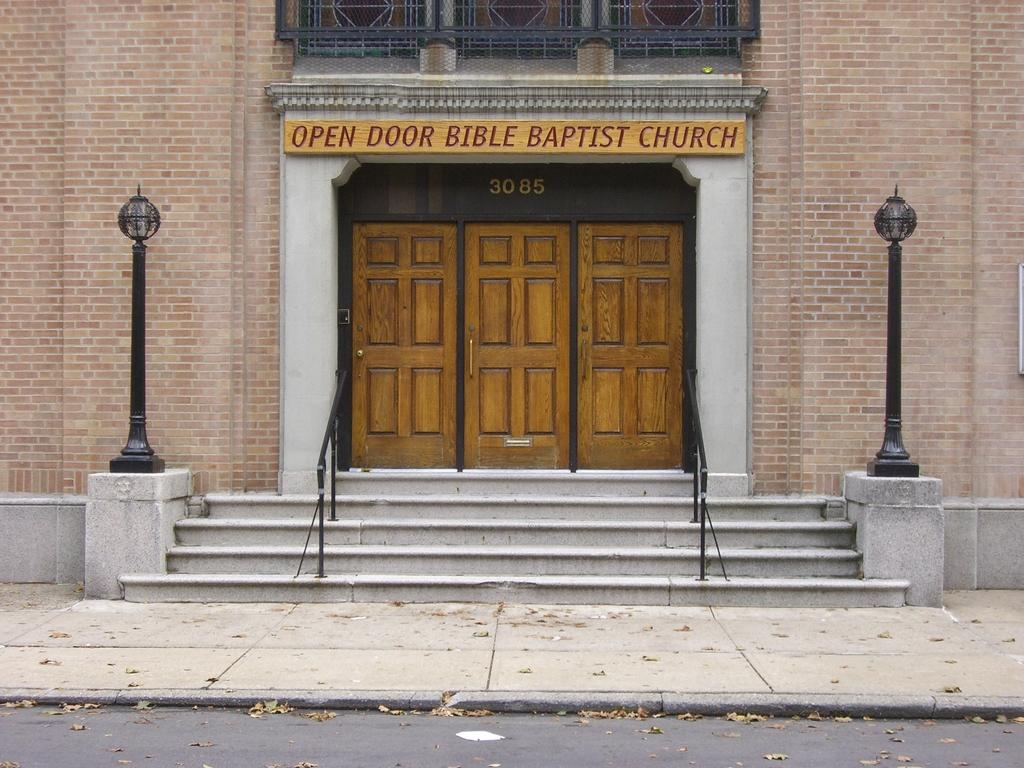What type of structure is shown in the image? The image depicts a building. What features of the building are visible in the image? The building has doors and stairs. Are there any lighting elements present in the image? Yes, there are lights visible in the image. How many representatives are present in the image? There are no representatives visible in the image; it depicts a building with doors, stairs, and lights. 